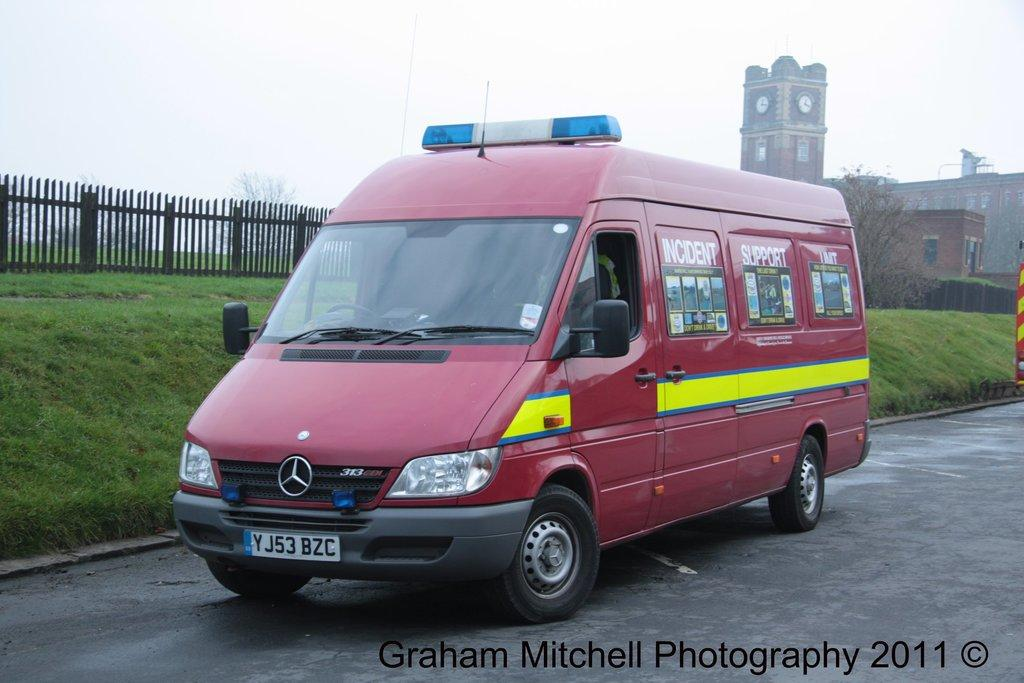<image>
Summarize the visual content of the image. an Incident Support van is parked along a grassy hill 